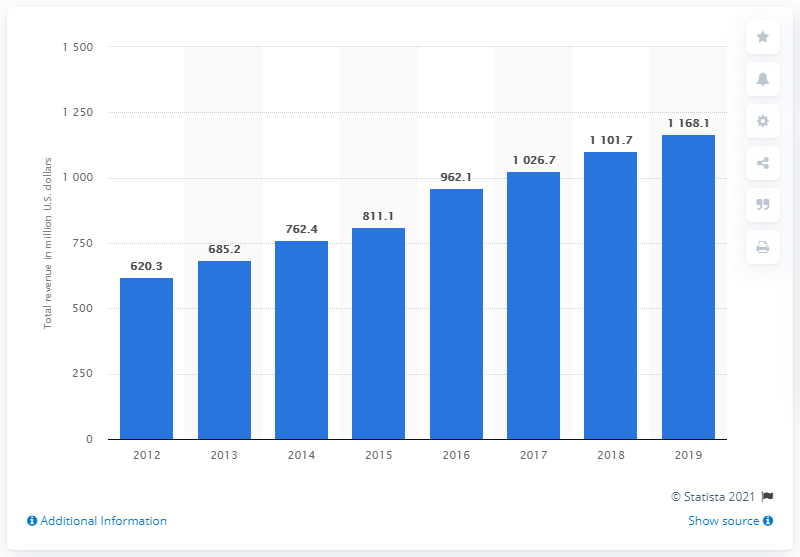Outline some significant characteristics in this image. NuVasive's revenue in 2019 was 1168.1 million dollars. NuVasive's annual revenue in 2014 was approximately $762.4 million. 